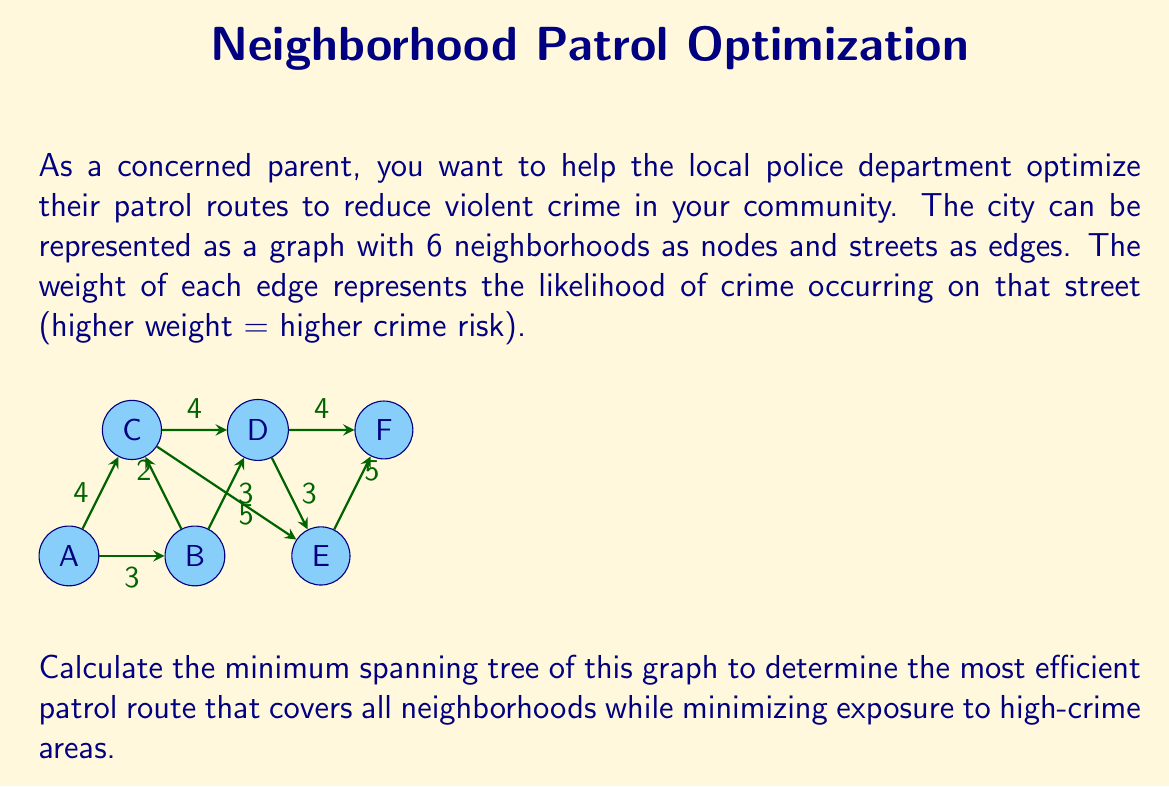Can you solve this math problem? To find the minimum spanning tree (MST) of this graph, we'll use Kruskal's algorithm. This algorithm finds the MST by selecting edges in order of increasing weight, avoiding any edges that would create a cycle.

Step 1: Sort the edges by weight in ascending order:
1. B-C (2)
2. A-B (3), D-E (3), B-D (3)
3. A-C (4), C-D (4), D-F (4)
4. E-F (5), C-E (5)

Step 2: Start adding edges to the MST, avoiding cycles:
1. Add B-C (2)
2. Add A-B (3)
3. Add D-E (3)
4. Add B-D (3) (A-C would create a cycle)
5. Add D-F (4)

The MST is now complete with 5 edges connecting all 6 vertices.

Total weight of the MST: $2 + 3 + 3 + 3 + 4 = 15$

This MST represents the optimal patrol route that covers all neighborhoods while minimizing exposure to high-crime areas.
Answer: MST edges: B-C, A-B, D-E, B-D, D-F; Total weight: 15 